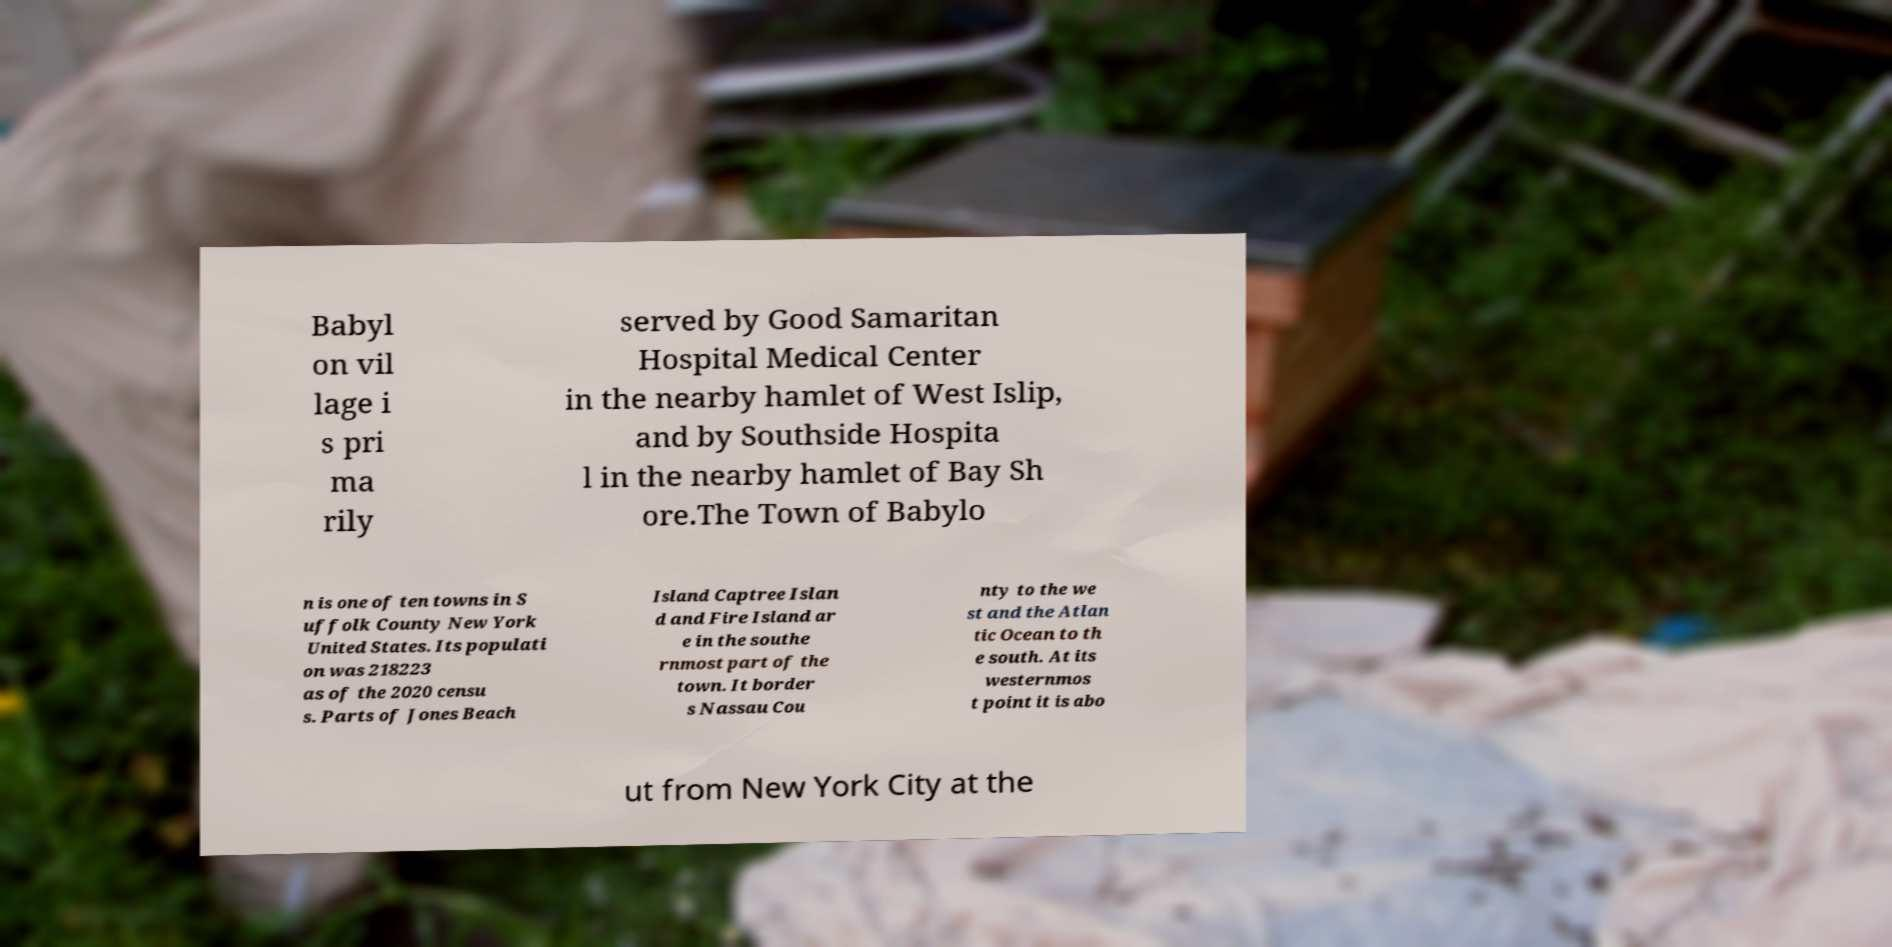Can you accurately transcribe the text from the provided image for me? Babyl on vil lage i s pri ma rily served by Good Samaritan Hospital Medical Center in the nearby hamlet of West Islip, and by Southside Hospita l in the nearby hamlet of Bay Sh ore.The Town of Babylo n is one of ten towns in S uffolk County New York United States. Its populati on was 218223 as of the 2020 censu s. Parts of Jones Beach Island Captree Islan d and Fire Island ar e in the southe rnmost part of the town. It border s Nassau Cou nty to the we st and the Atlan tic Ocean to th e south. At its westernmos t point it is abo ut from New York City at the 